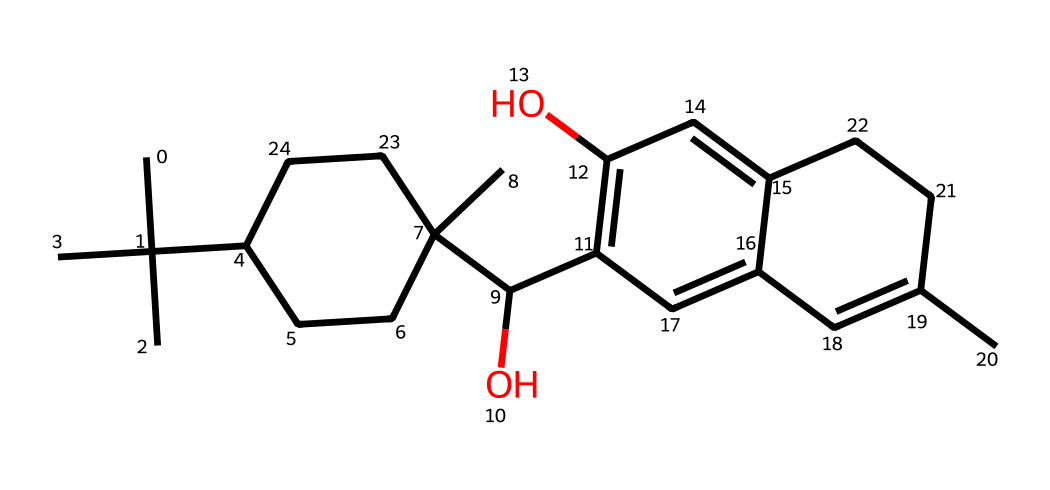What is the molecular formula of CBD? By analyzing the chemical structure represented in the SMILES notation, we count the number of each type of atom present. The structure contains 21 carbon atoms, 30 hydrogen atoms, and 2 oxygen atoms, leading to a molecular formula of C21H30O2.
Answer: C21H30O2 How many double bonds are present in CBD's structure? In the chemical structure, we observe the presence of double bonds by identifying the locations of unsaturation. The presence of two double bonds can be confirmed in the structure, specifically noted between certain carbon atoms.
Answer: 2 Does CBD contain any functional groups? By examining the structure, we look for specific arrangements of atoms that characterize functional groups. CBD possesses hydroxyl (−OH) groups indicated by the presence of oxygen bonded to carbon with hydrogen attached.
Answer: hydroxyl group What type of compound is CBD classified as? Based on its chemical structure, CBD is classified as a cannabinoid due to its origin from the cannabis plant and its chemical characteristics that align with other compounds in this class.
Answer: cannabinoid What is the significance of the cyclic structure in CBD? The presence of cyclic structures adds to the stability and rigidity of the molecule, which can influence its binding to receptors in the body and its overall bioactivity.
Answer: stability How many rings are present in CBD? Upon inspection of the structure, we identify two distinct cyclic components. Each ring contributes to the overall shape and pharmacological properties of the molecule.
Answer: 2 